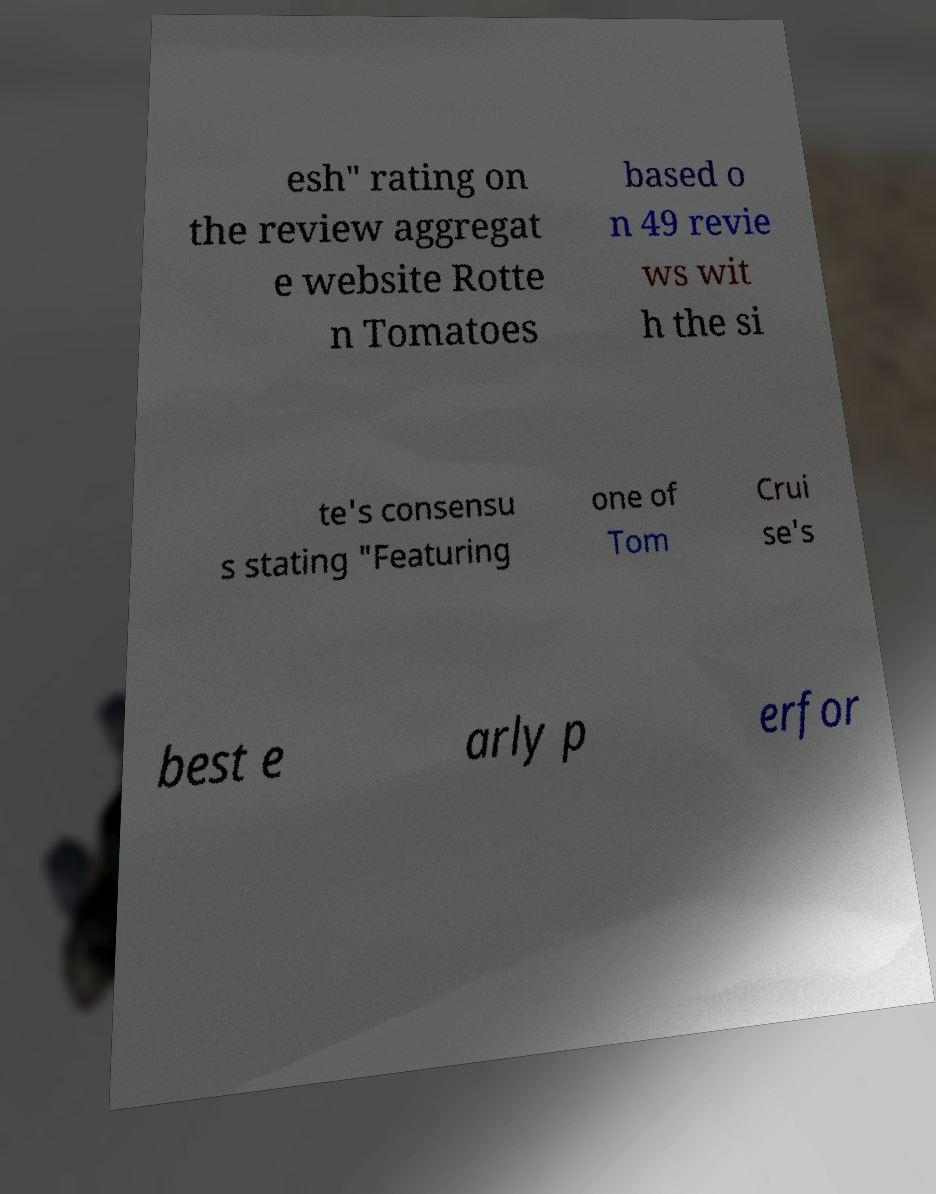Please identify and transcribe the text found in this image. esh" rating on the review aggregat e website Rotte n Tomatoes based o n 49 revie ws wit h the si te's consensu s stating "Featuring one of Tom Crui se's best e arly p erfor 